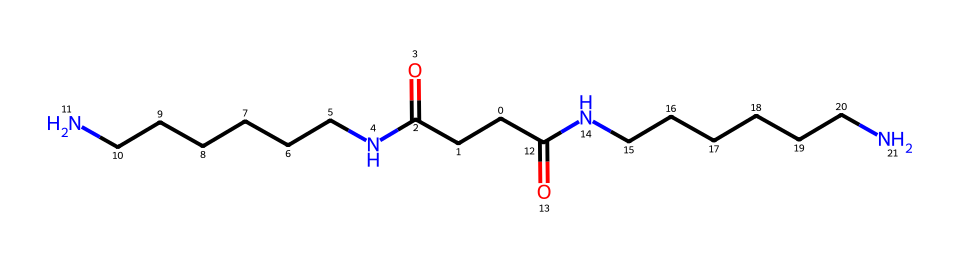What is the main functional group present in this chemical? The chemical contains a recurring amide functional group (–C(=O)N–), indicated by the presence of carbonyl (C=O) adjacent to nitrogen (N).
Answer: amide How many nitrogen atoms are present in the molecular structure? By examining the SMILES representation, there are two nitrogen atoms that can be counted, each connected to carbon chains providing structural integrity.
Answer: two What type of fibers does this compound represent? This compound is a synthetic polymer primarily used to make nylon fibers. Its repeating amide groups are characteristic of polyamides.
Answer: nylon Which element is most prominent in this structure? Carbon atoms are present throughout the entire structure, with a greater presence compared to nitrogen and oxygen, indicating they are the most numerous.
Answer: carbon What is the estimated molecular weight of this compound? By considering the number and types of atoms in the SMILES representation, the estimated molecular weight can be calculated, revealing it to be approximately 368.5 g/mol.
Answer: 368.5 